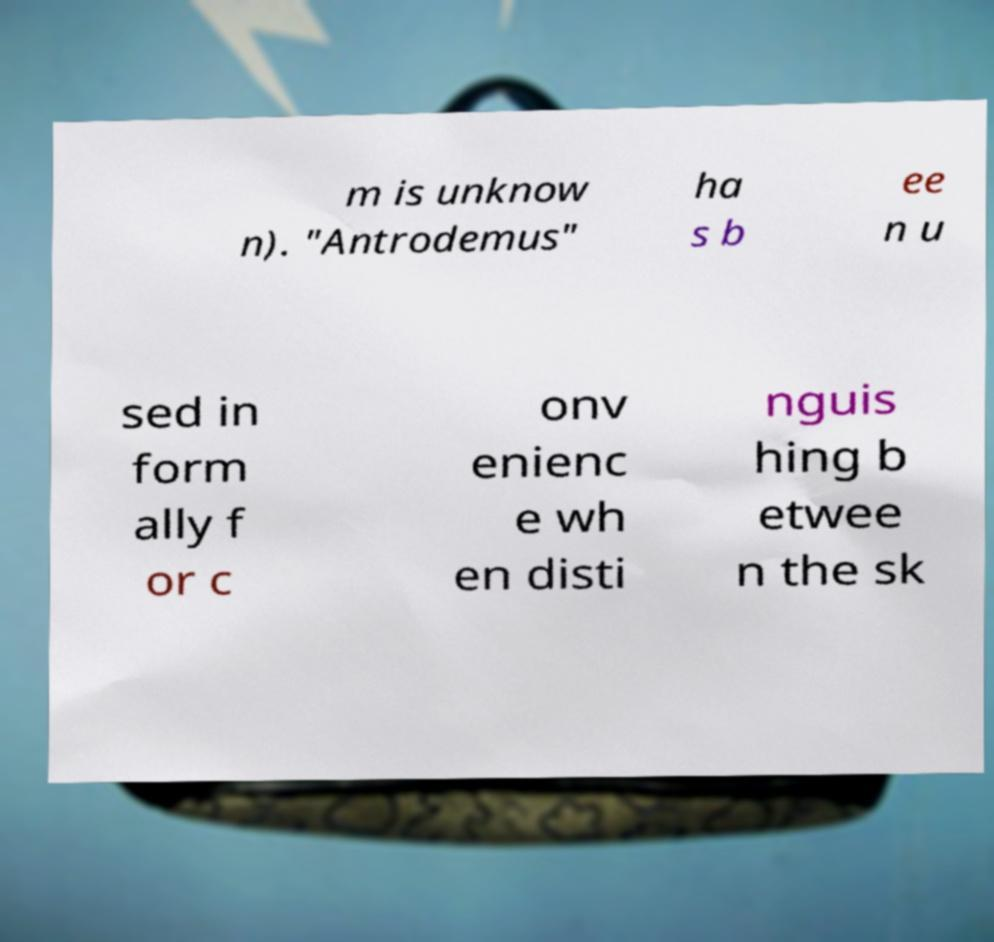Could you assist in decoding the text presented in this image and type it out clearly? m is unknow n). "Antrodemus" ha s b ee n u sed in form ally f or c onv enienc e wh en disti nguis hing b etwee n the sk 